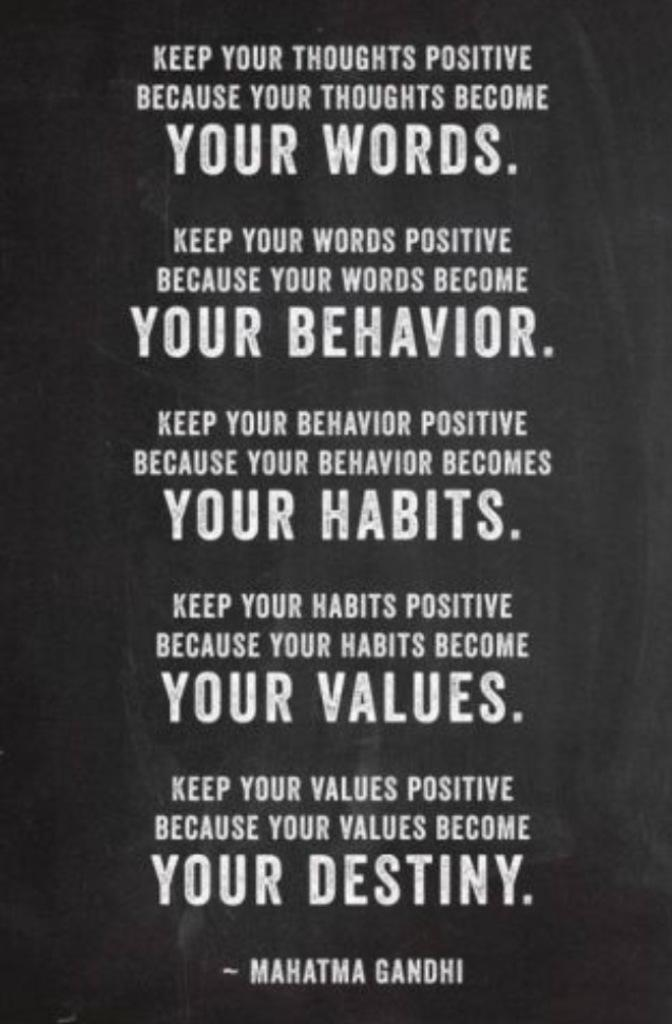<image>
Describe the image concisely. Gandhi quotes  are typed in white with a black background. 